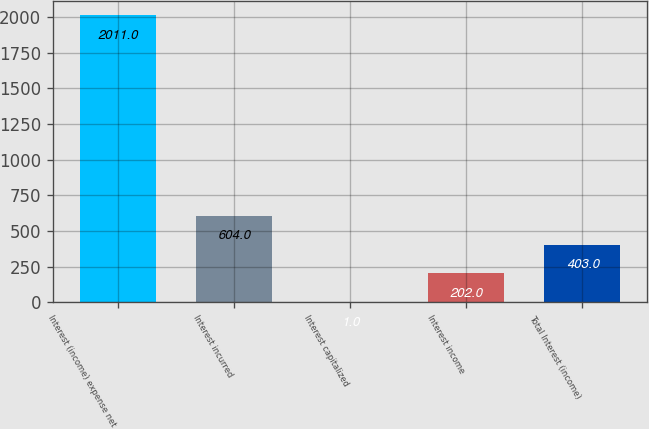<chart> <loc_0><loc_0><loc_500><loc_500><bar_chart><fcel>Interest (income) expense net<fcel>Interest incurred<fcel>Interest capitalized<fcel>Interest income<fcel>Total Interest (income)<nl><fcel>2011<fcel>604<fcel>1<fcel>202<fcel>403<nl></chart> 